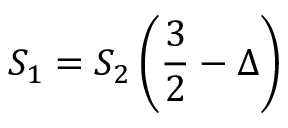Convert formula to latex. <formula><loc_0><loc_0><loc_500><loc_500>S _ { 1 } = S _ { 2 } \left ( \frac { 3 } { 2 } - \Delta \right )</formula> 